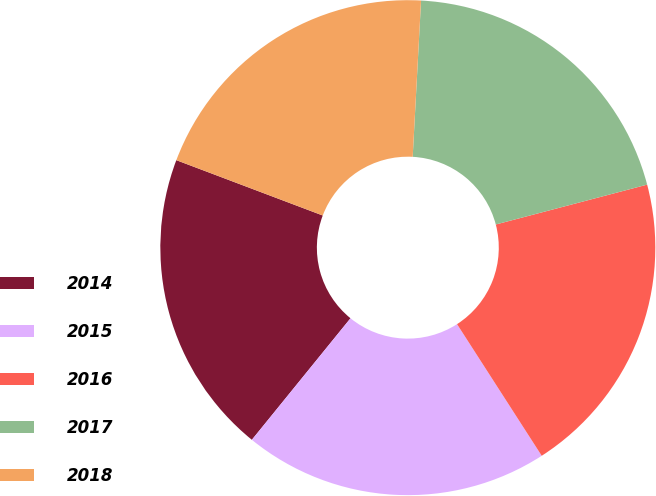<chart> <loc_0><loc_0><loc_500><loc_500><pie_chart><fcel>2014<fcel>2015<fcel>2016<fcel>2017<fcel>2018<nl><fcel>19.9%<fcel>19.95%<fcel>20.0%<fcel>20.05%<fcel>20.1%<nl></chart> 